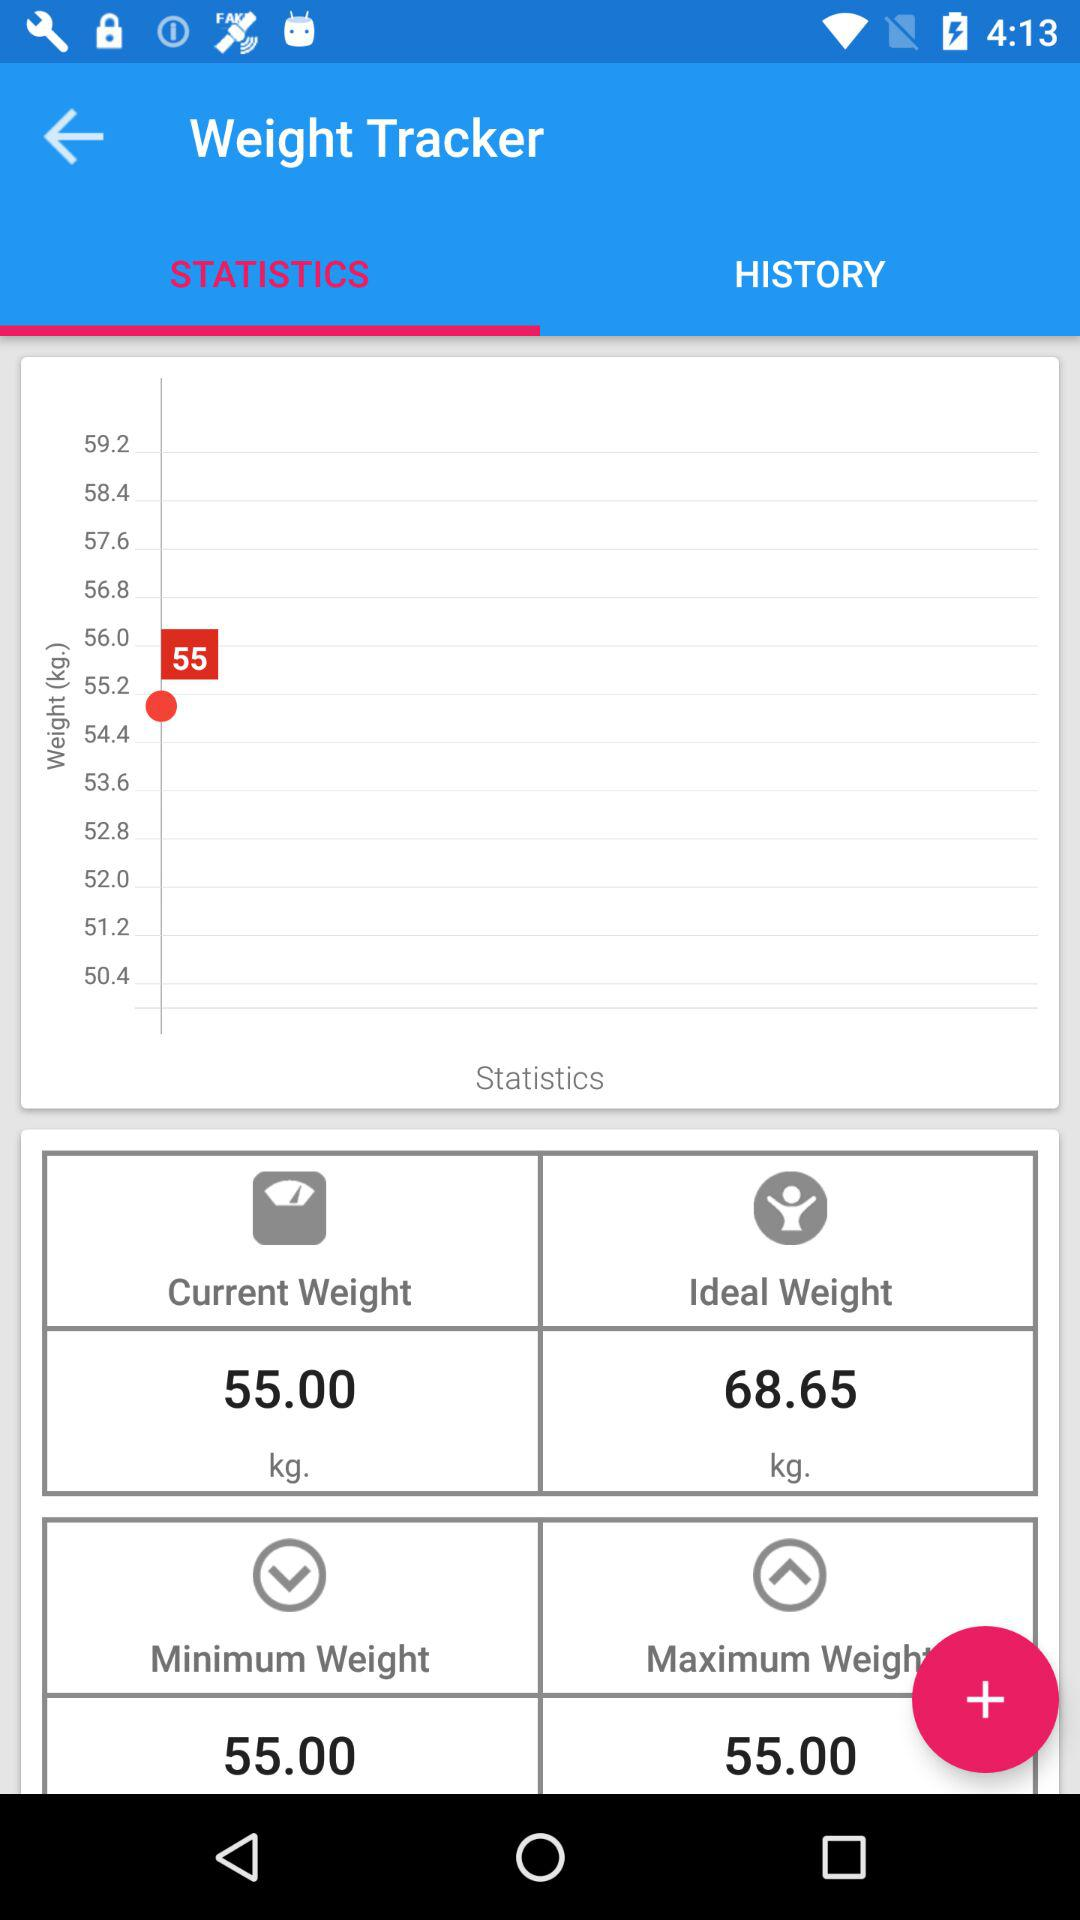What is the difference between the minimum and maximum weight?
Answer the question using a single word or phrase. 13.65 